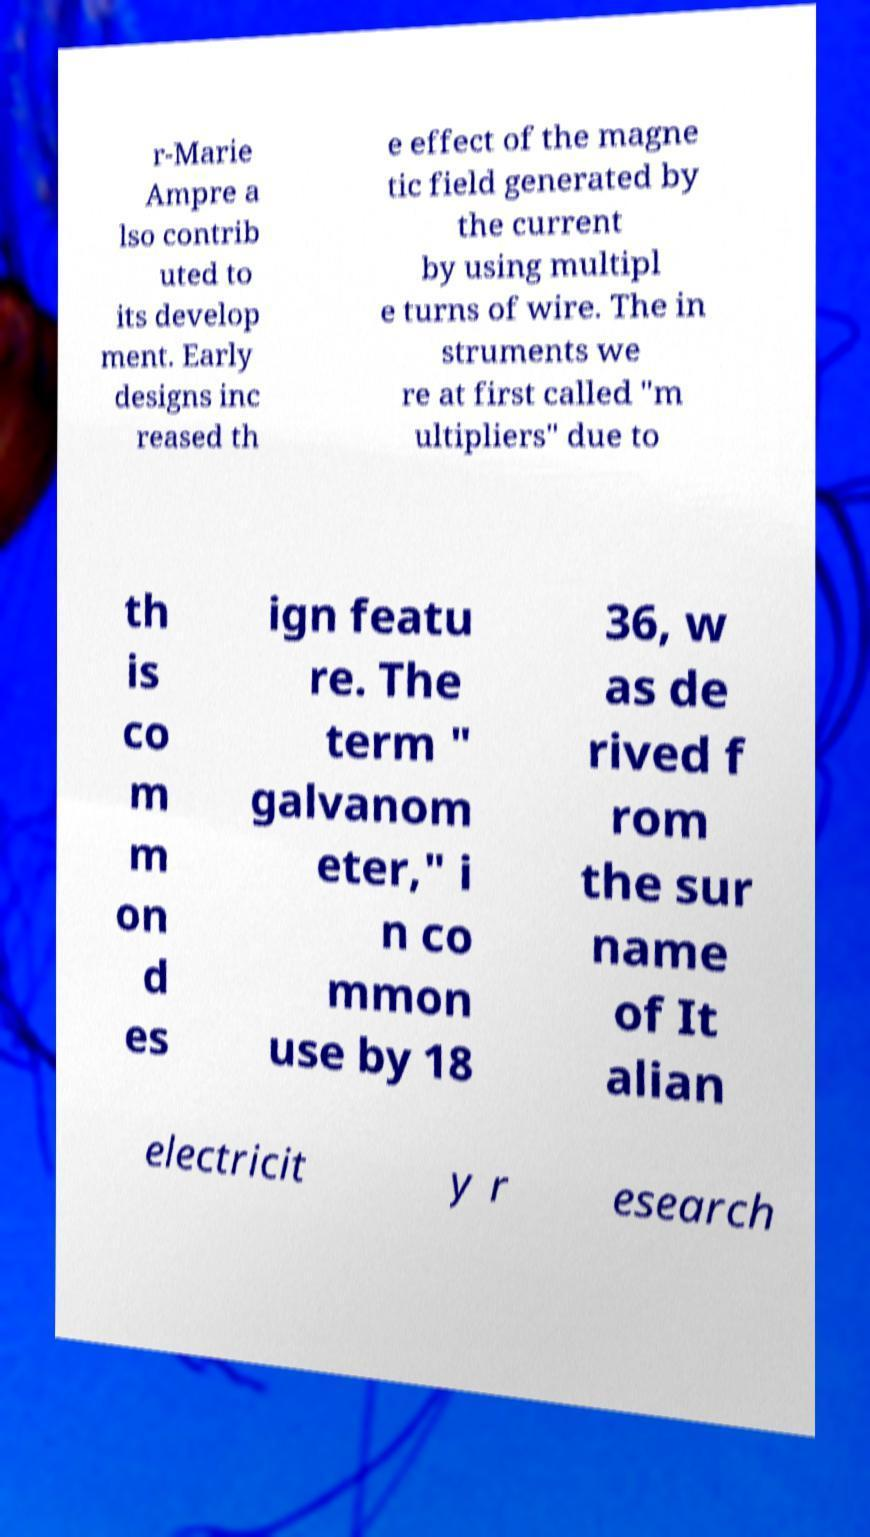For documentation purposes, I need the text within this image transcribed. Could you provide that? r-Marie Ampre a lso contrib uted to its develop ment. Early designs inc reased th e effect of the magne tic field generated by the current by using multipl e turns of wire. The in struments we re at first called "m ultipliers" due to th is co m m on d es ign featu re. The term " galvanom eter," i n co mmon use by 18 36, w as de rived f rom the sur name of It alian electricit y r esearch 